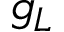Convert formula to latex. <formula><loc_0><loc_0><loc_500><loc_500>g _ { L }</formula> 